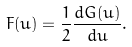<formula> <loc_0><loc_0><loc_500><loc_500>F ( u ) = \frac { 1 } { 2 } \frac { d G ( u ) } { d u } .</formula> 